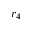Convert formula to latex. <formula><loc_0><loc_0><loc_500><loc_500>r _ { 4 }</formula> 